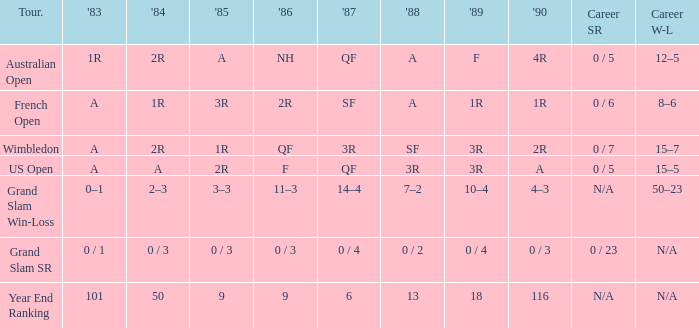What is the result in 1985 when the career win-loss is n/a, and 0 / 23 as the career SR? 0 / 3. 